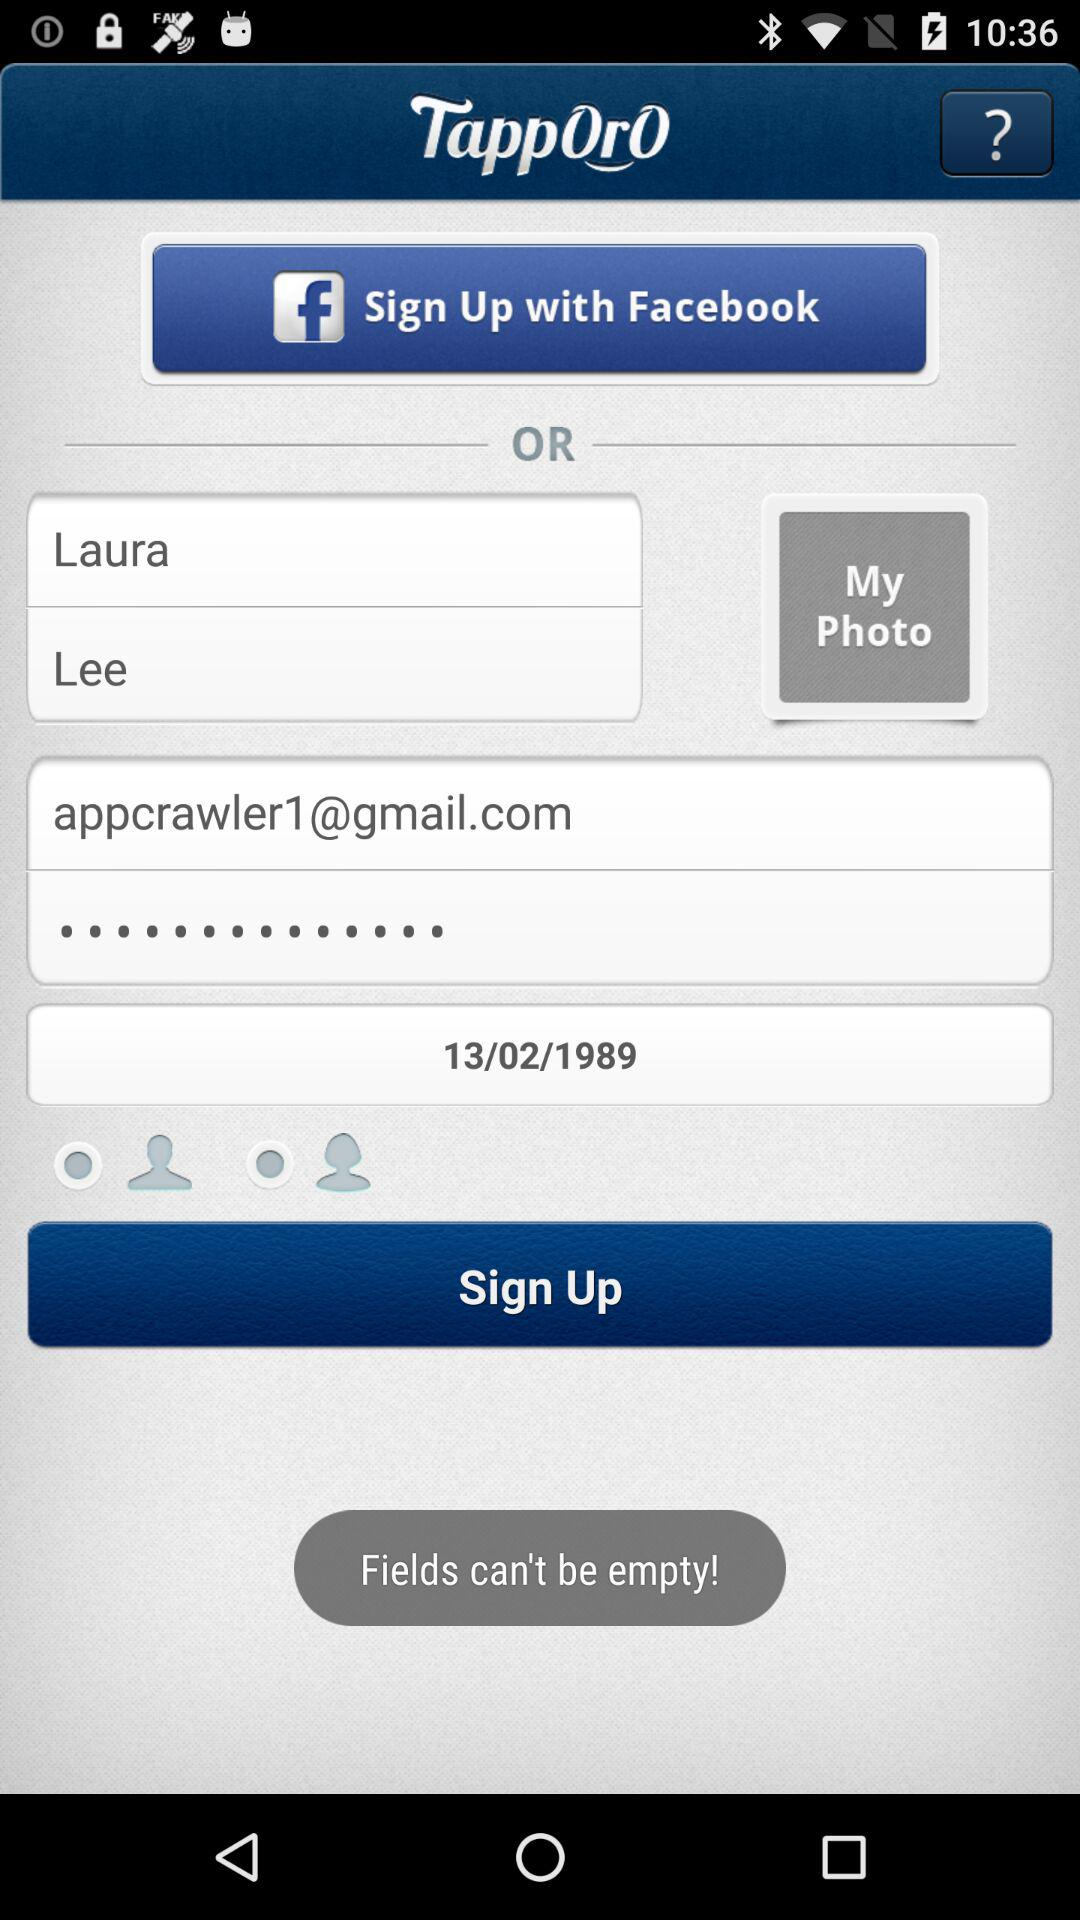How many required fields are there?
Answer the question using a single word or phrase. 3 